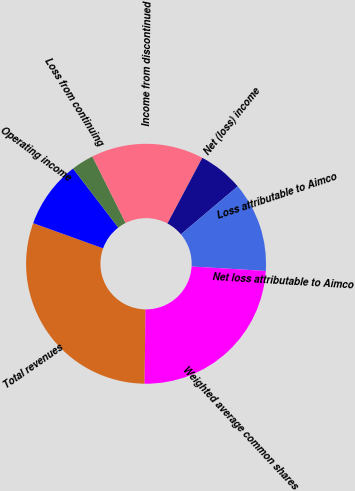Convert chart. <chart><loc_0><loc_0><loc_500><loc_500><pie_chart><fcel>Total revenues<fcel>Operating income<fcel>Loss from continuing<fcel>Income from discontinued<fcel>Net (loss) income<fcel>Loss attributable to Aimco<fcel>Net loss attributable to Aimco<fcel>Weighted average common shares<nl><fcel>30.3%<fcel>9.09%<fcel>3.03%<fcel>15.15%<fcel>6.06%<fcel>12.12%<fcel>0.0%<fcel>24.24%<nl></chart> 